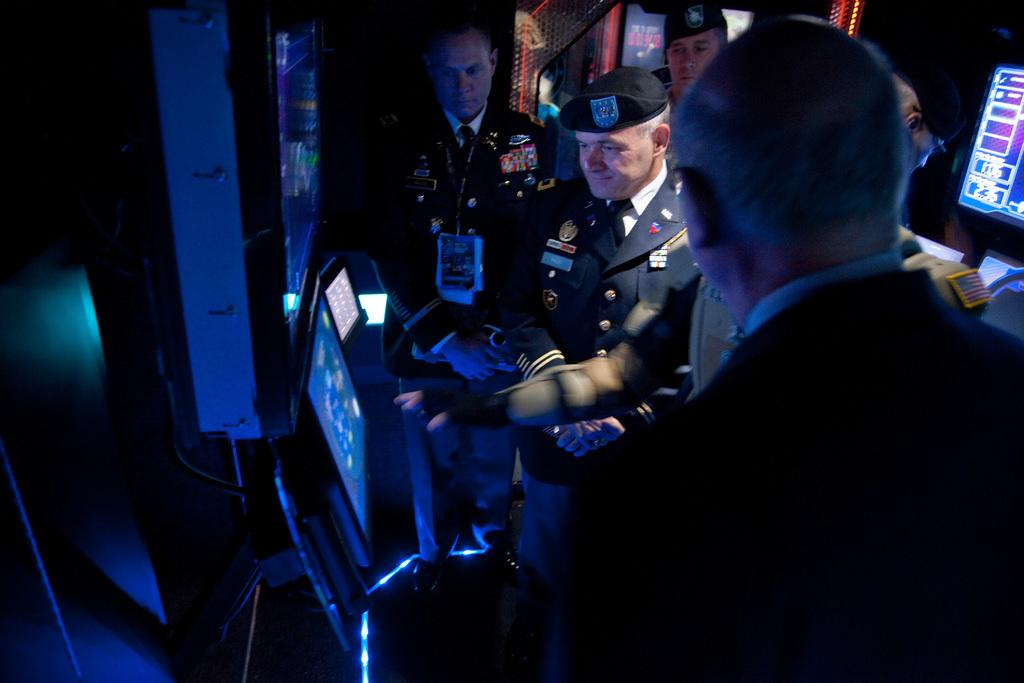What are the people in the image doing? The people in the image are standing on the floor. What can be seen on the screens in the image? There are screens present in the image, but their content is not specified. What other objects are visible in the image? There are other objects in the image, but their nature is not described. How would you describe the lighting in the image? The background of the image is dark. What type of yam is being served in the image? There is no yam present in the image. Can you hear the bell ringing in the image? There is no bell present in the image, so it cannot be heard. 